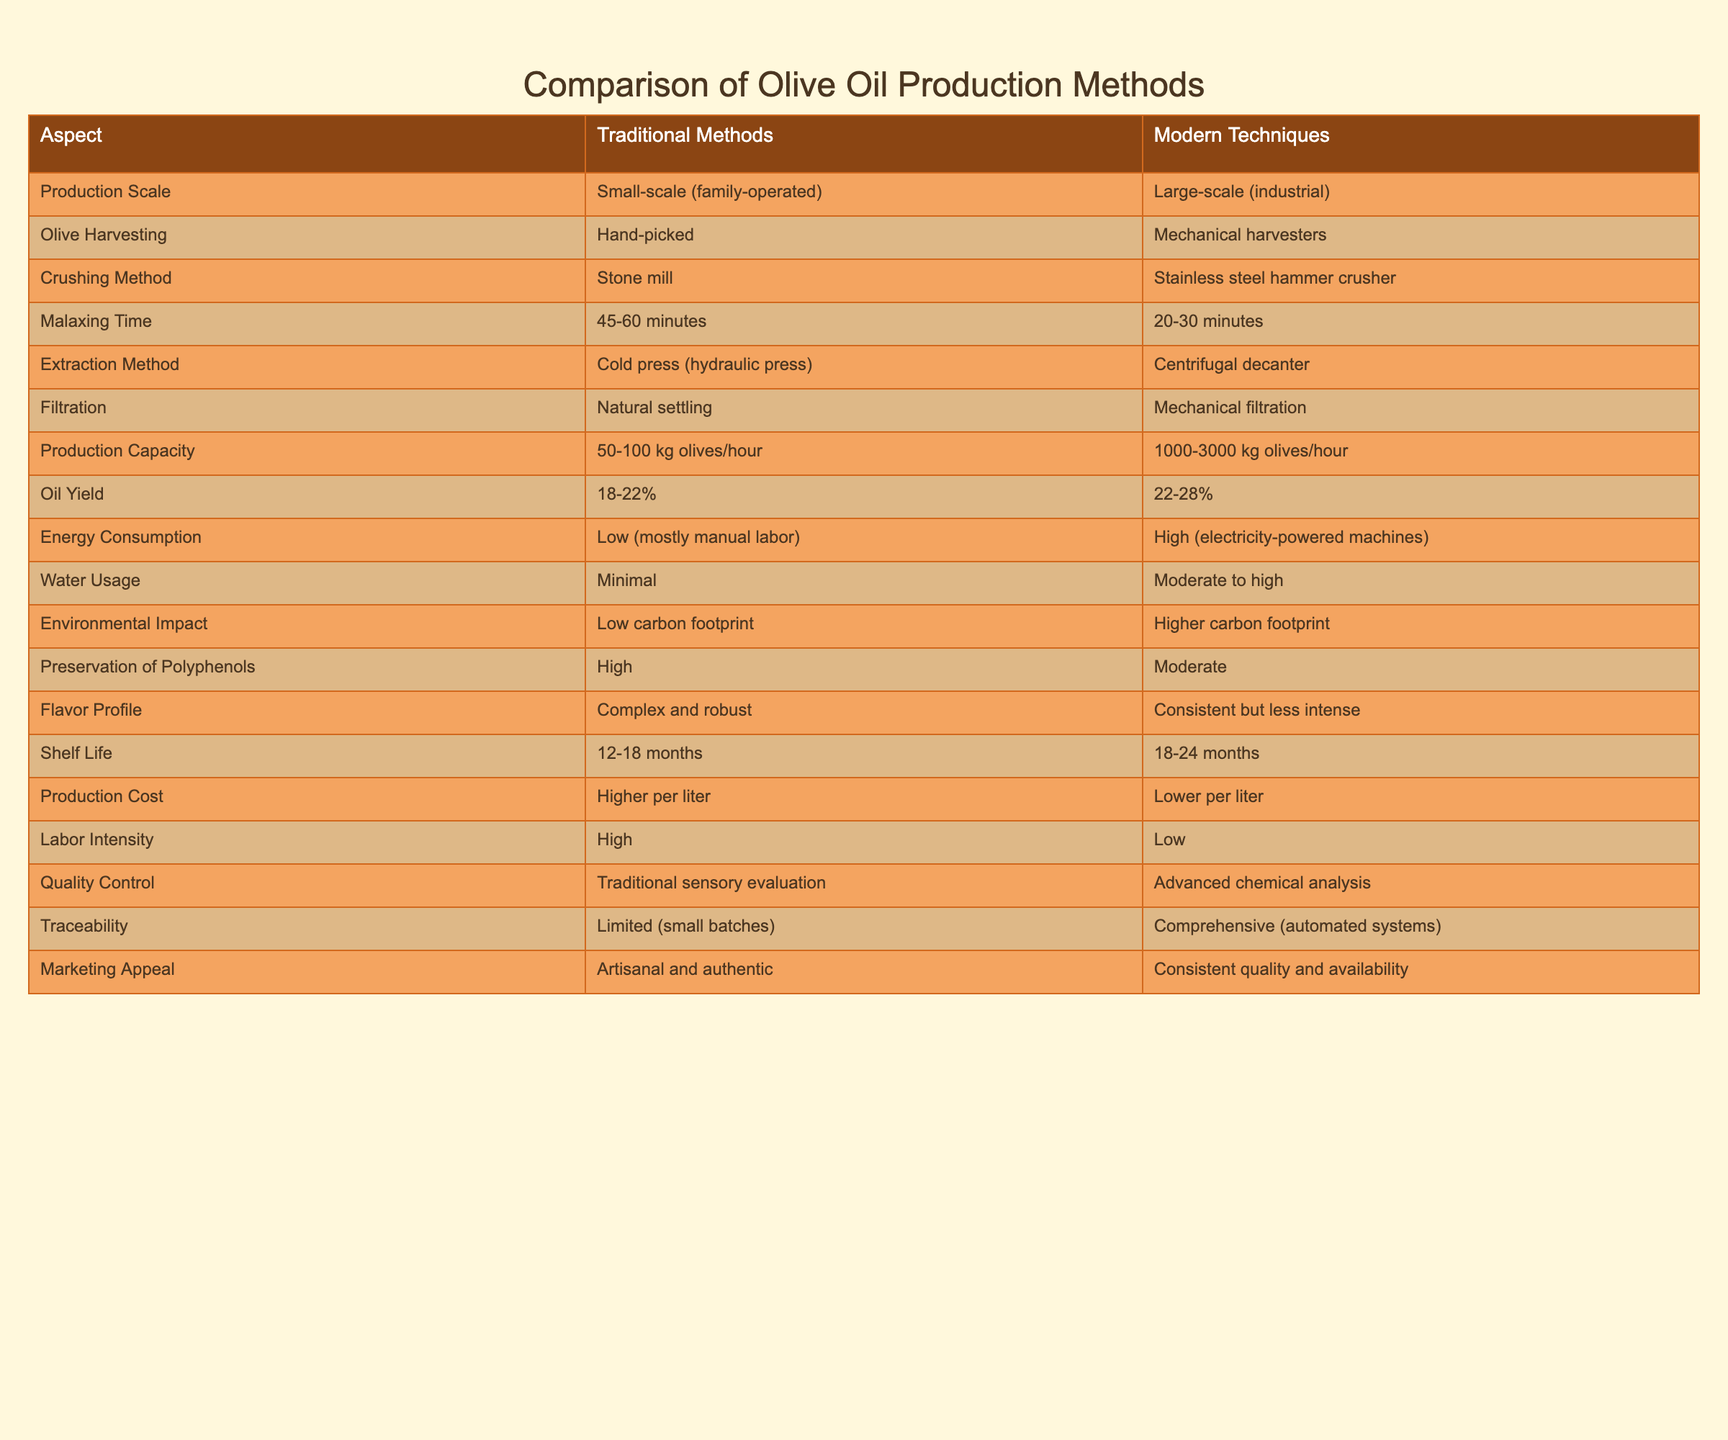What is the oil yield percentage for traditional methods? Referring to the table, the oil yield percentage for traditional methods is listed directly in the row under "Oil Yield" as 18-22%.
Answer: 18-22% What is the production capacity range for modern techniques? In the table, the "Production Capacity" for modern techniques is shown as 1000-3000 kg olives/hour.
Answer: 1000-3000 kg olives/hour True or False: Traditional methods use mechanical harvesters for olive harvesting. The table indicates that traditional methods use hand-picking for harvesting, while modern techniques use mechanical harvesters. Thus, the statement is false.
Answer: False What is the difference in malaxing time between traditional and modern techniques? The malaxing time for traditional methods is 45-60 minutes, and for modern techniques, it is 20-30 minutes. The difference is calculated by subtracting the upper end of modern techniques from the lower end of traditional techniques (45 - 30 = 15) and the lower end of traditional from the upper end of modern techniques (60 - 20 = 40). So, the difference range is 15-40 minutes.
Answer: 15-40 minutes Which method has a higher carbon footprint? The table states that traditional methods have a low carbon footprint, while modern techniques have a higher carbon footprint. This clearly indicates which method is less environmentally friendly.
Answer: Modern techniques What is the average preservation duration for oil produced using modern techniques as compared to traditional methods? The preservation duration for modern techniques is listed as 18-24 months, and for traditional methods, it is 12-18 months. To find the average, we calculate the average range for each: traditional (12+18)/2 = 15 months, modern (18+24)/2 = 21 months. Thus, modern techniques have an average preservation duration of 21 months compared to 15 months for traditional methods. The difference is 21 - 15 = 6 months.
Answer: Modern: 21 months, Traditional: 15 months, Difference: 6 months Is labor intensity higher in traditional methods compared to modern techniques? The table shows that traditional methods have a high labor intensity, while modern techniques have a low labor intensity. So, this statement is true.
Answer: Yes How does the flavor profile differ between methods? According to the table, traditional methods produce a complex and robust flavor profile, whereas modern techniques yield a consistent but less intense flavor profile. This shows the distinct differences in taste outcomes between the two methods.
Answer: Traditional: Complex and robust, Modern: Consistent but less intense What percentage of energy consumption is considered high for modern techniques? Based on the table, modern techniques have high energy consumption which is noted to be electricity-powered machines, while traditional methods have low consumption mostly due to manual labor. Thus, it confirms that modern techniques involve a higher energy percentage but does not quantify it in percentage terms.
Answer: High (exact percentage not specified) 